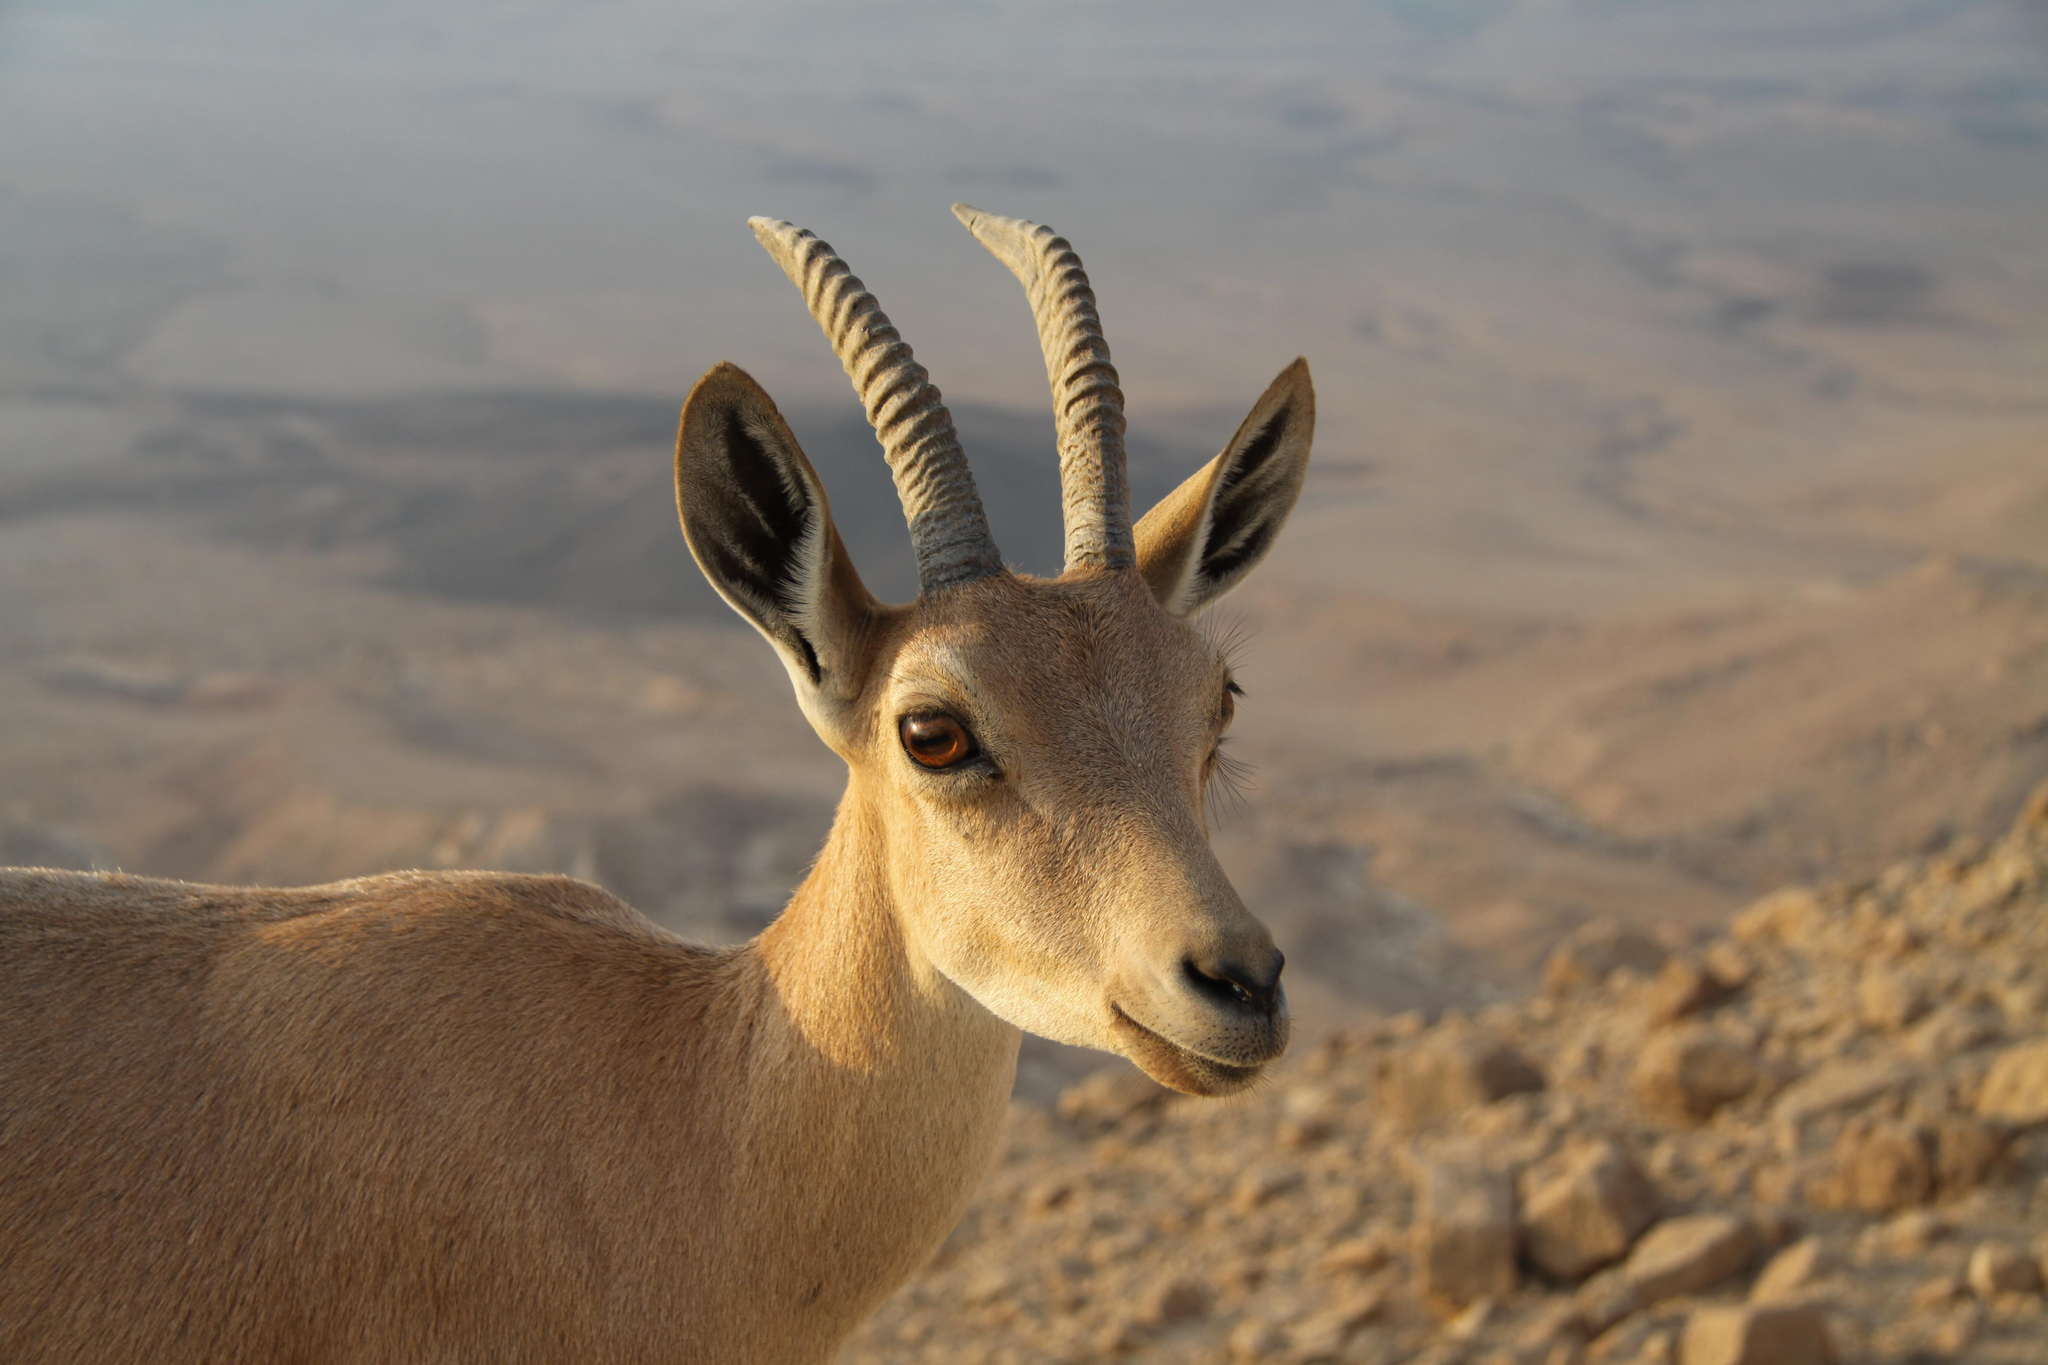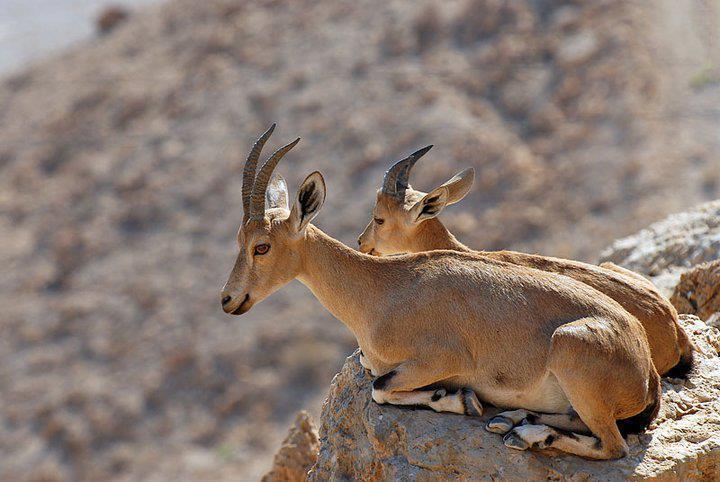The first image is the image on the left, the second image is the image on the right. Considering the images on both sides, is "In one image, at least one horned animal is lying down with its legs tucked under it." valid? Answer yes or no. Yes. 